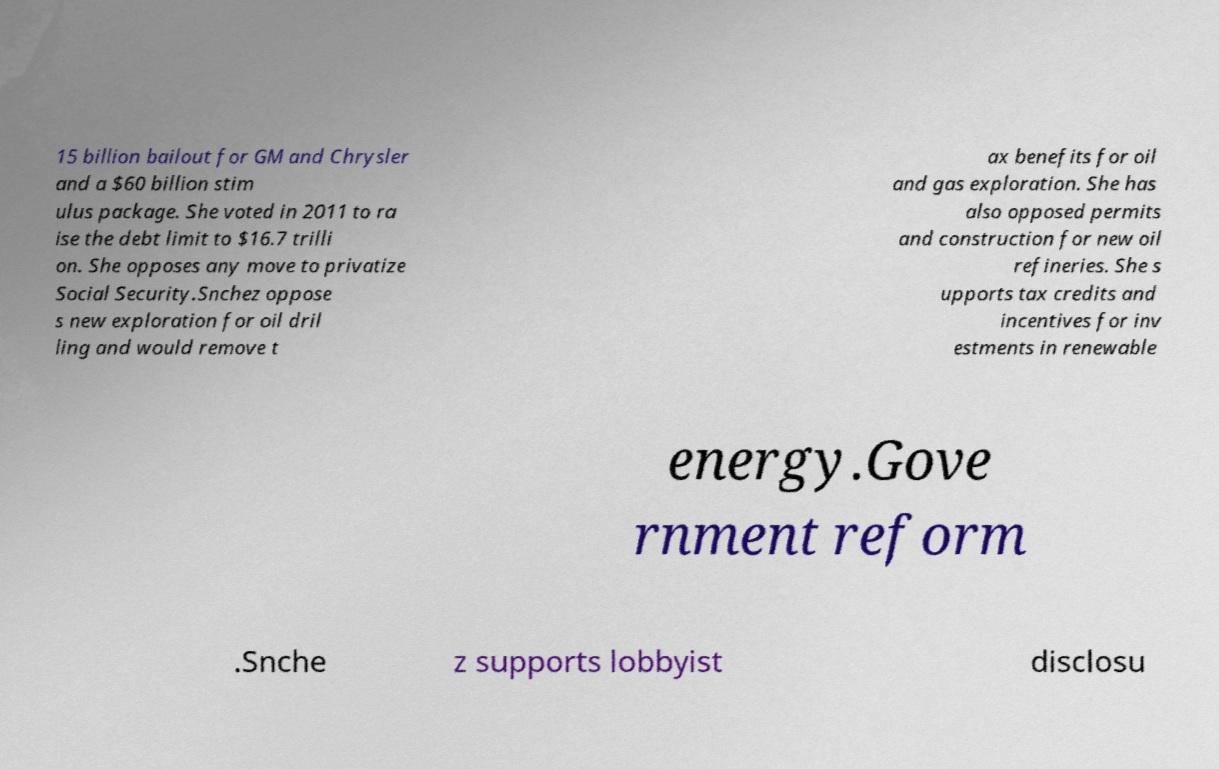Can you accurately transcribe the text from the provided image for me? 15 billion bailout for GM and Chrysler and a $60 billion stim ulus package. She voted in 2011 to ra ise the debt limit to $16.7 trilli on. She opposes any move to privatize Social Security.Snchez oppose s new exploration for oil dril ling and would remove t ax benefits for oil and gas exploration. She has also opposed permits and construction for new oil refineries. She s upports tax credits and incentives for inv estments in renewable energy.Gove rnment reform .Snche z supports lobbyist disclosu 